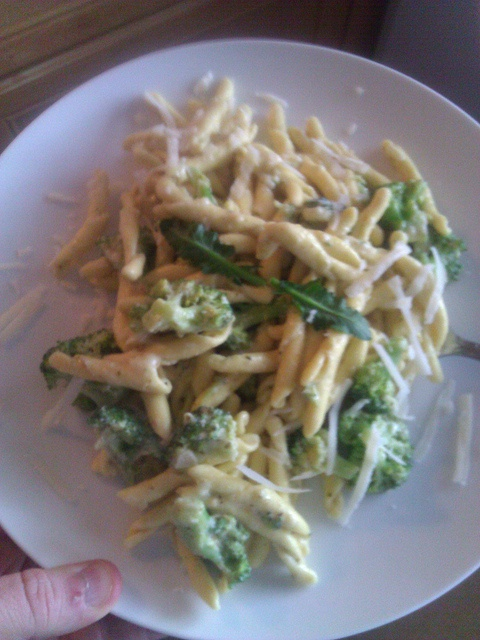Describe the objects in this image and their specific colors. I can see people in purple, darkgray, gray, and violet tones, broccoli in purple, darkgray, teal, green, and lightblue tones, broccoli in purple, gray, olive, and darkgray tones, broccoli in purple, gray, teal, and darkgray tones, and broccoli in purple, black, gray, and darkgreen tones in this image. 